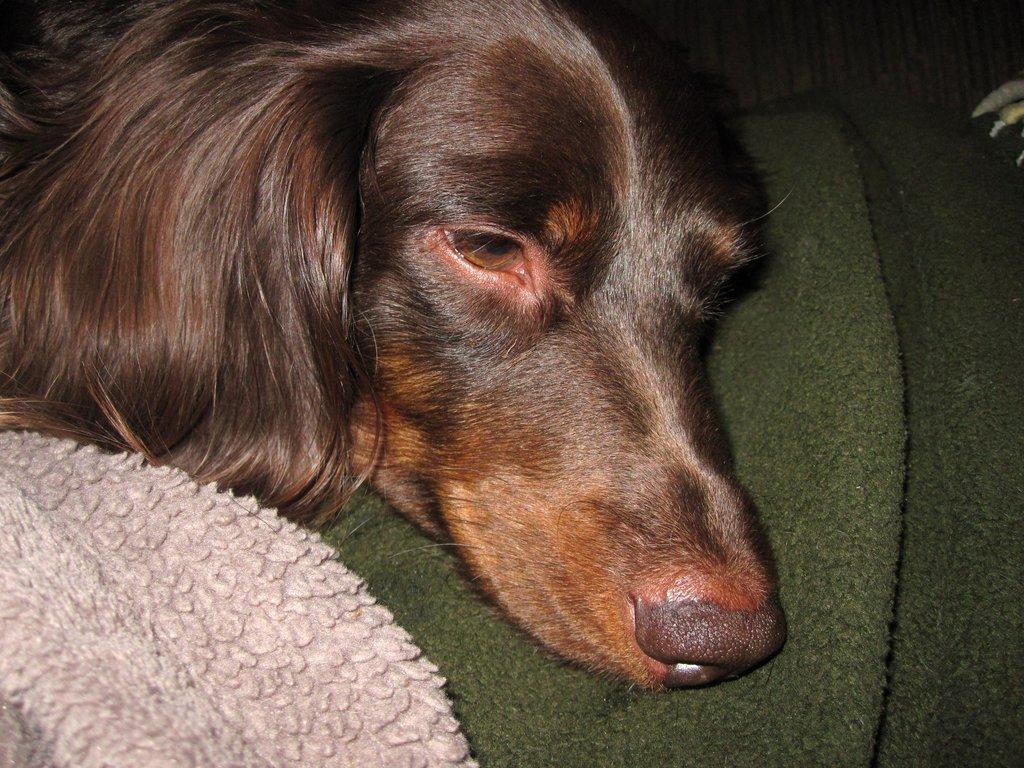What animal is present in the image? There is a dog in the image. Where is the dog located? The dog is on a towel. What type of feast is being prepared on the towel in the image? There is no feast or preparation of food visible in the image; it only features a dog on a towel. 